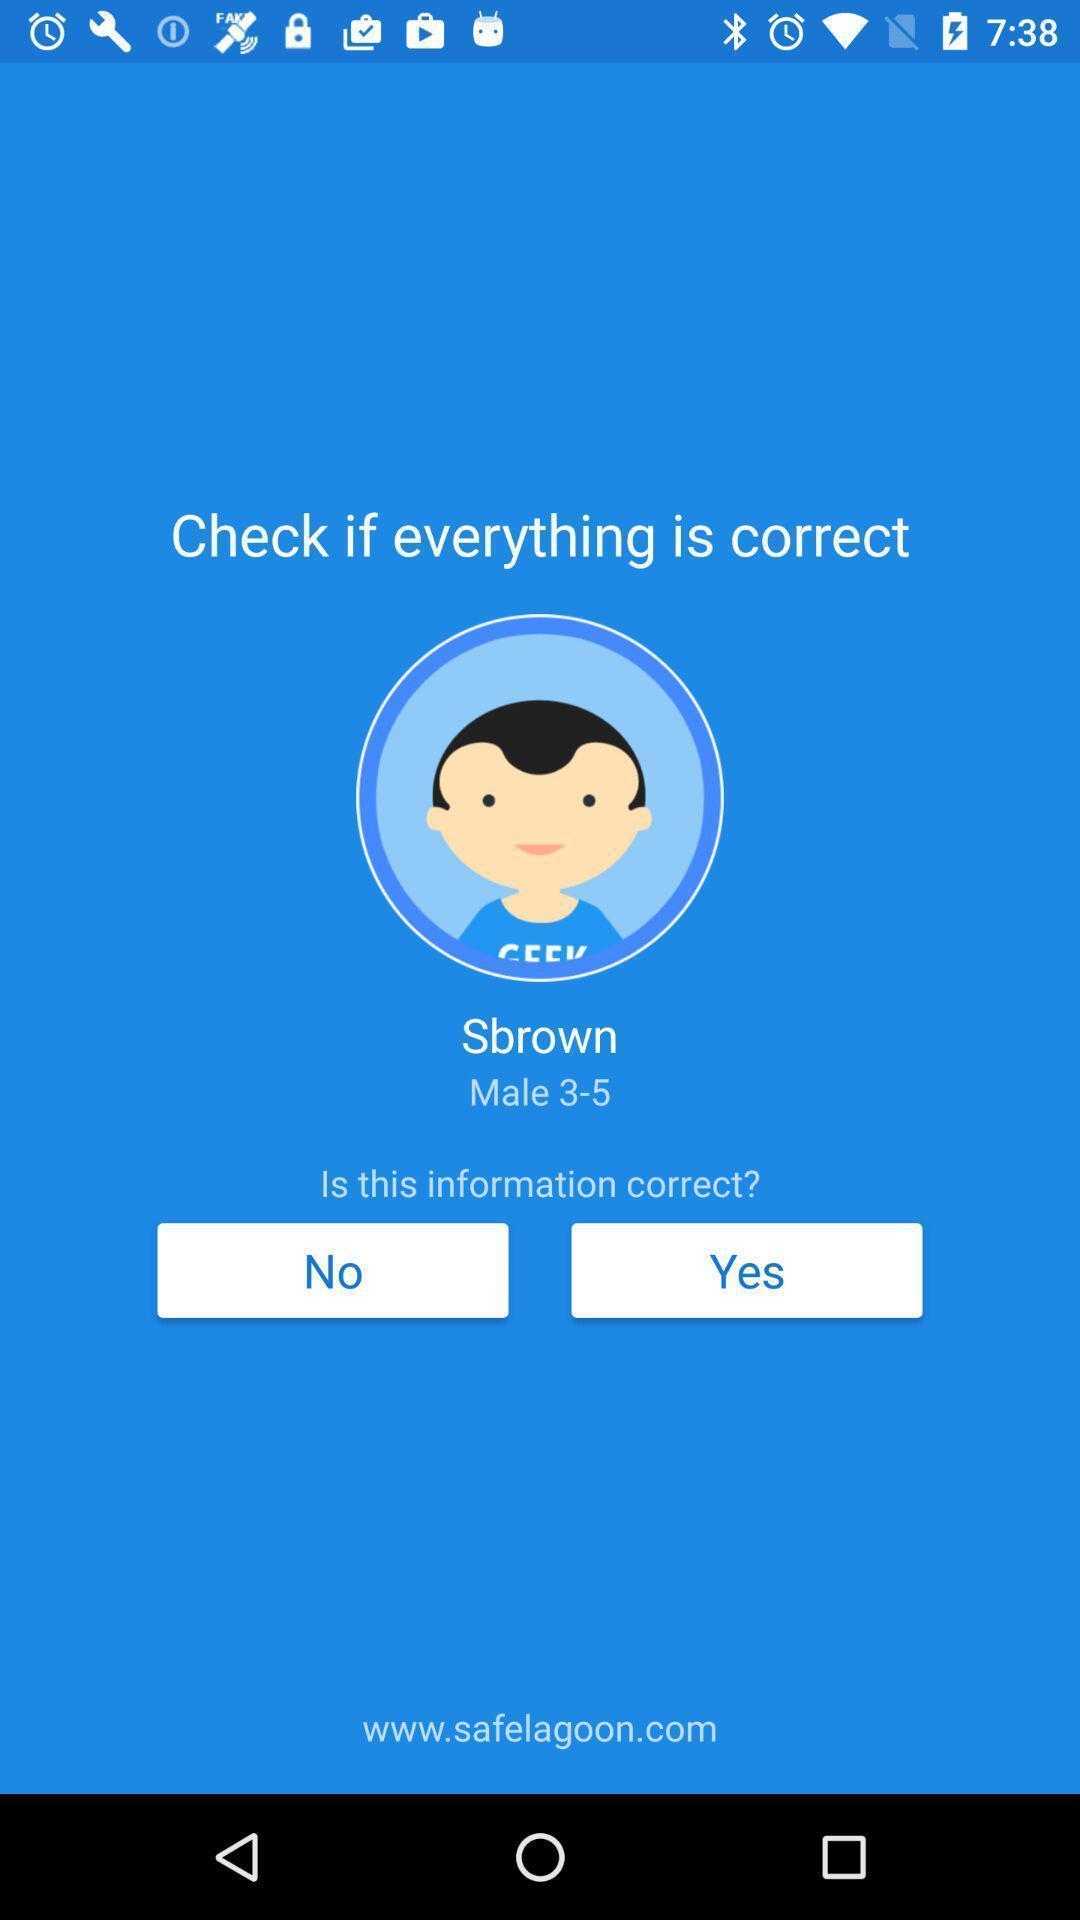Explain what's happening in this screen capture. Screen showing profile confirmation page. 